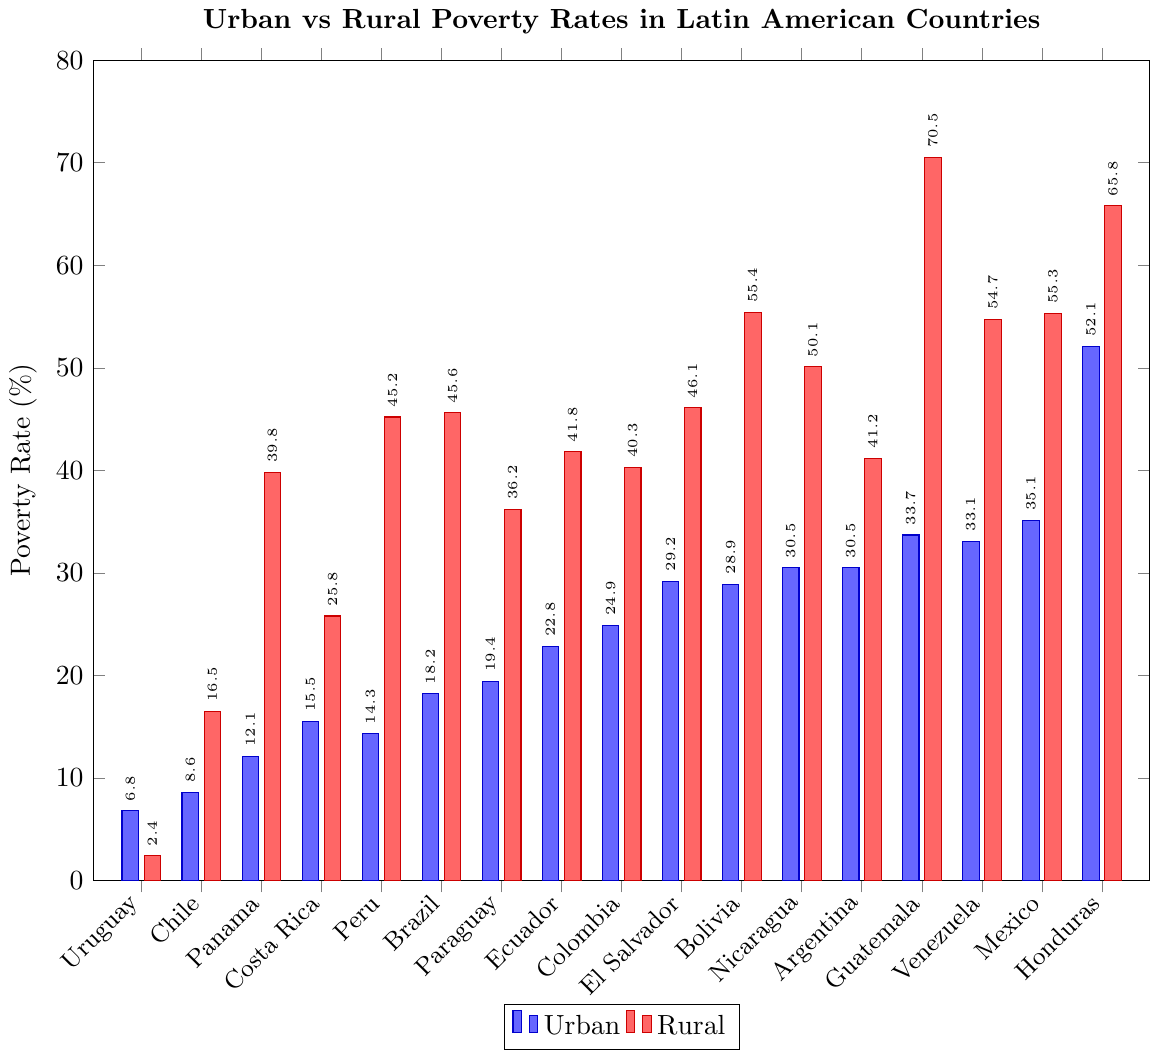What's the urban poverty rate in Brazil? Look for Brazil in the x-axis and check the blue bar height corresponding to it.
Answer: 18.2% Which country has the highest rural poverty rate? Scan through the red bars and identify the one with the greatest height, noting the country on the x-axis.
Answer: Guatemala Compare the urban and rural poverty rates in Argentina. Which one is higher and by how much? Find Argentina on the x-axis, note the blue and red bar heights, and calculate the difference: 41.2 (rural) - 30.5 (urban).
Answer: Rural, by 10.7% What is the average urban poverty rate for Uruguay, Chile, and Panama? Note the urban poverty rates for these countries (Uruguay: 6.8, Chile: 8.6, Panama: 12.1), sum them up and divide by 3: (6.8 + 8.6 + 12.1)/3
Answer: 9.17% By how much does the rural poverty rate in Paraguay exceed its urban poverty rate? Find Paraguay on the x-axis, note the blue and red bar heights, and calculate the difference: 36.2 (rural) - 19.4 (urban).
Answer: 16.8% Identify the countries where the urban and rural poverty rates do not exceed 50%. Look for blue and red bars where both heights are below 50%, noting the corresponding countries.
Answer: Uruguay, Chile, Costa Rica, Panama Which country has the smallest difference between urban and rural poverty rates? Calculate the absolute differences for all countries and identify the smallest one. Differences: Uruguay (4.4), Chile (7.9), etc.
Answer: Uruguay What is the combined poverty rate (urban + rural) for Venezuela? Add the values of the blue and red bars for Venezuela: 33.1 + 54.7
Answer: 87.8% Is the urban poverty rate higher in Mexico or Colombia? Compare the heights of the blue bars for Mexico and Colombia.
Answer: Mexico Sum the rural poverty rates of Bolivia and Honduras. Add the rural poverty rates of Bolivia (55.4) and Honduras (65.8).
Answer: 121.2% 